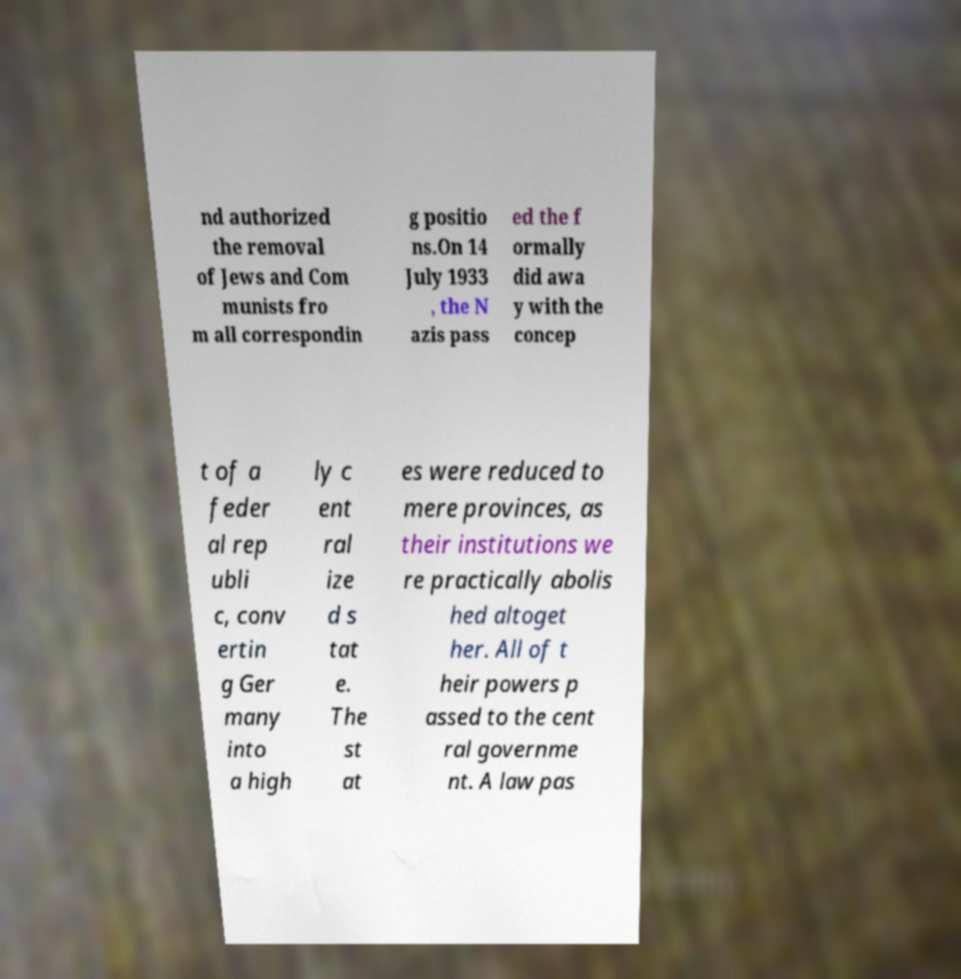There's text embedded in this image that I need extracted. Can you transcribe it verbatim? nd authorized the removal of Jews and Com munists fro m all correspondin g positio ns.On 14 July 1933 , the N azis pass ed the f ormally did awa y with the concep t of a feder al rep ubli c, conv ertin g Ger many into a high ly c ent ral ize d s tat e. The st at es were reduced to mere provinces, as their institutions we re practically abolis hed altoget her. All of t heir powers p assed to the cent ral governme nt. A law pas 